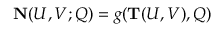Convert formula to latex. <formula><loc_0><loc_0><loc_500><loc_500>{ N } ( U , V ; Q ) = g ( { T } ( U , V ) , Q )</formula> 